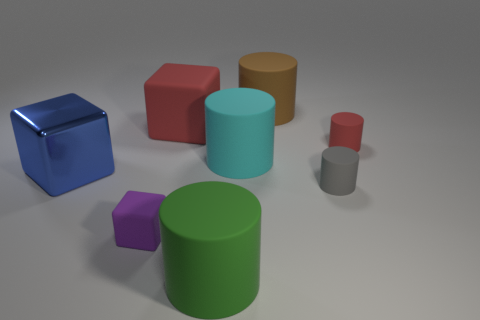There is a tiny thing that is the same color as the large matte block; what is it made of?
Offer a very short reply. Rubber. There is a large object that is in front of the large blue block; does it have the same color as the metal thing?
Provide a short and direct response. No. There is a small matte object on the left side of the big rubber object that is on the left side of the large green rubber object; what is its shape?
Your answer should be very brief. Cube. Is the number of big matte objects that are on the right side of the large red block less than the number of green matte objects that are behind the purple object?
Give a very brief answer. No. What size is the purple matte object that is the same shape as the blue thing?
Offer a terse response. Small. Are there any other things that have the same size as the metallic object?
Offer a terse response. Yes. How many objects are either cylinders that are to the right of the big green object or large objects that are on the left side of the cyan rubber thing?
Provide a succinct answer. 7. Is the size of the brown object the same as the purple block?
Provide a short and direct response. No. Is the number of green objects greater than the number of cylinders?
Offer a very short reply. No. How many other objects are the same color as the small rubber block?
Keep it short and to the point. 0. 